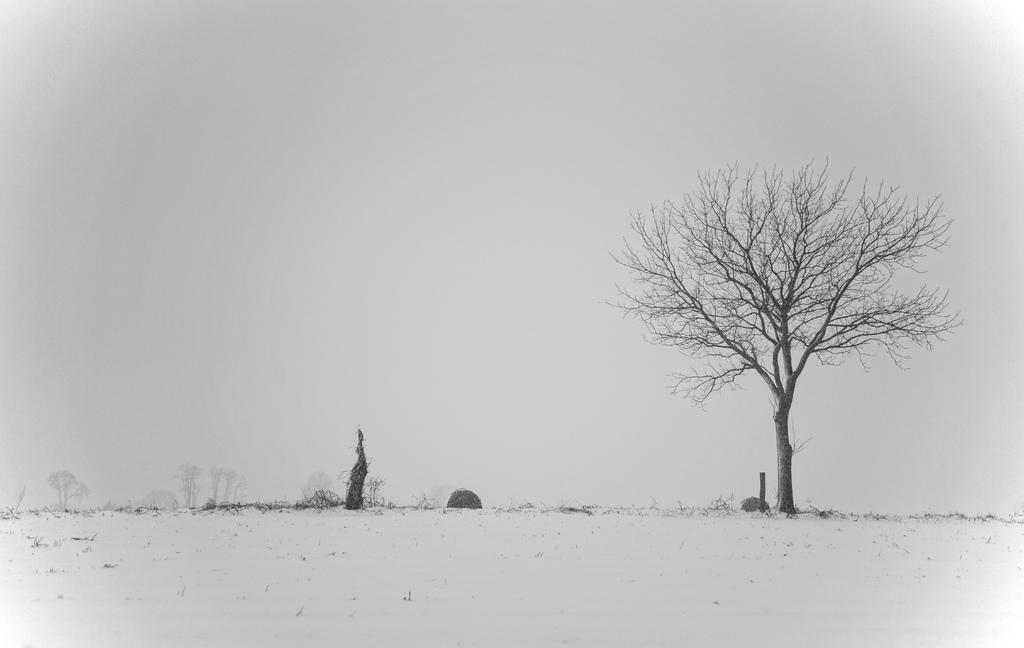Please provide a concise description of this image. This is a black and white pic. In this image we can see bare trees and plants on the ground and we can see the sky. 